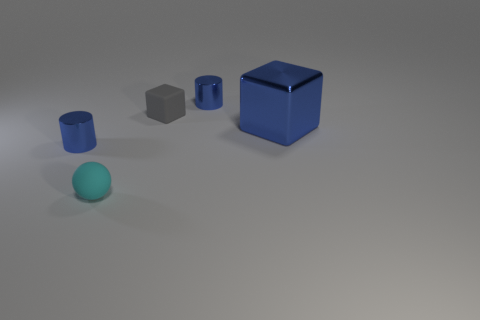Is there any other thing that is the same size as the blue cube?
Provide a succinct answer. No. Are there any other cyan balls made of the same material as the cyan sphere?
Your answer should be very brief. No. What is the color of the cylinder to the right of the tiny blue metal cylinder that is in front of the thing behind the gray thing?
Offer a very short reply. Blue. Is the color of the small cylinder left of the cyan matte ball the same as the object behind the tiny block?
Your response must be concise. Yes. Are there any other things of the same color as the sphere?
Ensure brevity in your answer.  No. Is the number of cyan matte balls that are to the left of the tiny cyan rubber ball less than the number of rubber blocks?
Offer a very short reply. Yes. What number of big blue rubber balls are there?
Offer a very short reply. 0. Does the gray object have the same shape as the big thing to the right of the tiny gray object?
Your response must be concise. Yes. Are there fewer shiny cylinders that are on the right side of the large blue shiny block than tiny objects to the left of the tiny cyan rubber object?
Keep it short and to the point. Yes. Is there anything else that is the same shape as the small cyan rubber thing?
Your answer should be compact. No. 